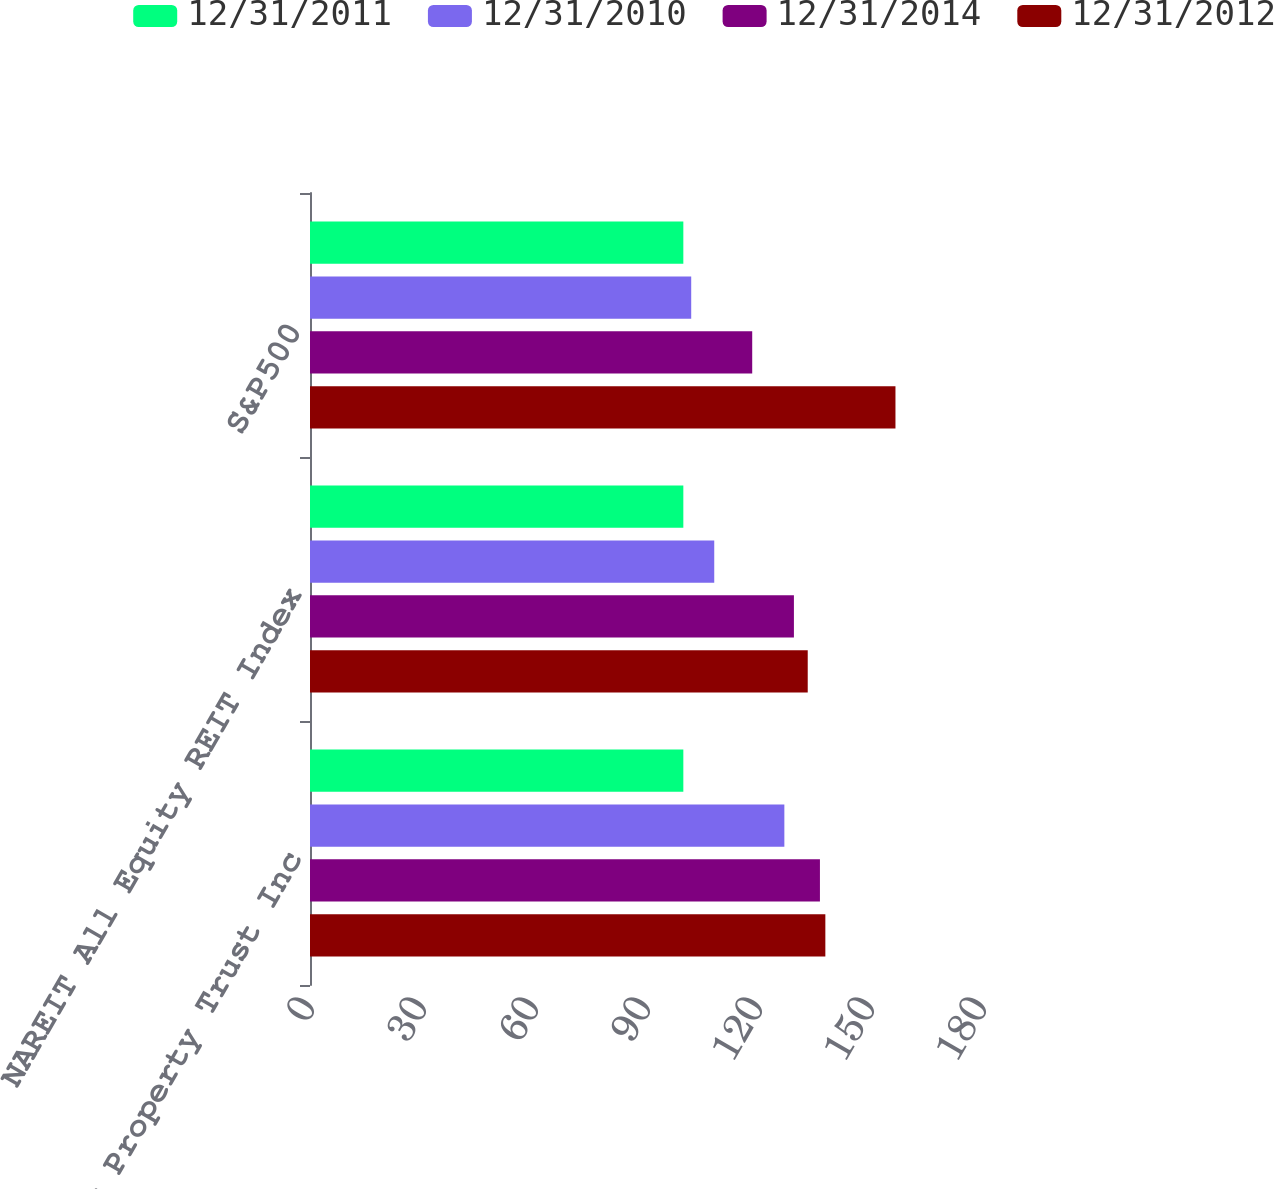<chart> <loc_0><loc_0><loc_500><loc_500><stacked_bar_chart><ecel><fcel>Essex Property Trust Inc<fcel>NAREIT All Equity REIT Index<fcel>S&P500<nl><fcel>12/31/2011<fcel>100<fcel>100<fcel>100<nl><fcel>12/31/2010<fcel>127.06<fcel>108.28<fcel>102.11<nl><fcel>12/31/2014<fcel>136.59<fcel>129.62<fcel>118.45<nl><fcel>12/31/2012<fcel>138.04<fcel>133.32<fcel>156.82<nl></chart> 